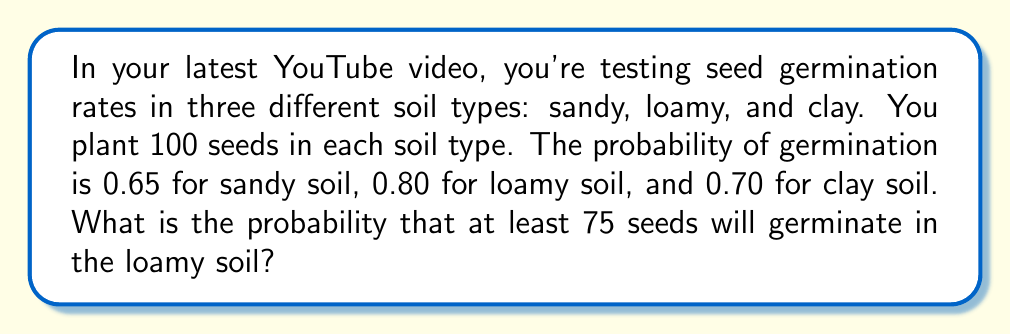Provide a solution to this math problem. To solve this problem, we'll use the binomial distribution, as we're dealing with a fixed number of independent trials (planting 100 seeds) with two possible outcomes for each trial (germinate or not germinate).

Let X be the number of seeds that germinate in loamy soil.
X follows a binomial distribution with n = 100 and p = 0.80.

We need to find P(X ≥ 75).

Step 1: Calculate P(X < 75) using the normal approximation to the binomial distribution.
(We can use this approximation because np and n(1-p) are both greater than 5.)

Mean (μ) = np = 100 * 0.80 = 80
Standard deviation (σ) = √(np(1-p)) = √(100 * 0.80 * 0.20) = 4

Step 2: Apply continuity correction and calculate the z-score:
z = (74.5 - 80) / 4 = -1.375

Step 3: Use the standard normal distribution table or a calculator to find P(Z < -1.375) ≈ 0.0846

Step 4: Calculate P(X ≥ 75):
P(X ≥ 75) = 1 - P(X < 75) = 1 - 0.0846 = 0.9154

Therefore, the probability that at least 75 seeds will germinate in the loamy soil is approximately 0.9154 or 91.54%.
Answer: 0.9154 